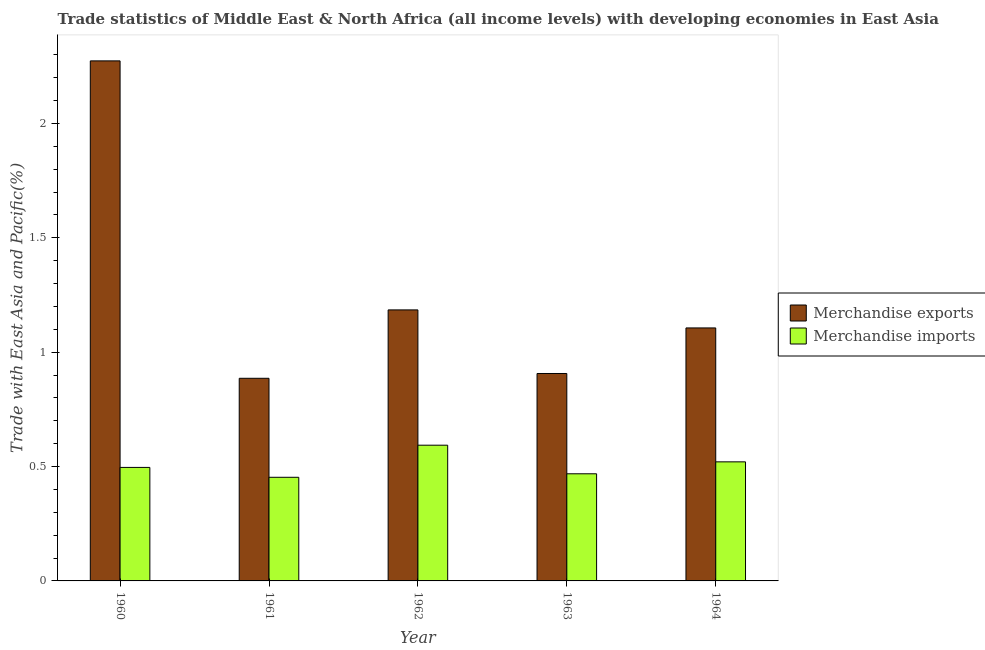How many different coloured bars are there?
Provide a short and direct response. 2. How many groups of bars are there?
Give a very brief answer. 5. How many bars are there on the 3rd tick from the left?
Your answer should be very brief. 2. How many bars are there on the 2nd tick from the right?
Your answer should be compact. 2. What is the label of the 5th group of bars from the left?
Ensure brevity in your answer.  1964. In how many cases, is the number of bars for a given year not equal to the number of legend labels?
Offer a very short reply. 0. What is the merchandise exports in 1962?
Provide a short and direct response. 1.19. Across all years, what is the maximum merchandise imports?
Give a very brief answer. 0.59. Across all years, what is the minimum merchandise exports?
Your answer should be very brief. 0.89. What is the total merchandise imports in the graph?
Your answer should be compact. 2.53. What is the difference between the merchandise imports in 1961 and that in 1963?
Offer a very short reply. -0.02. What is the difference between the merchandise exports in 1963 and the merchandise imports in 1964?
Your answer should be very brief. -0.2. What is the average merchandise imports per year?
Provide a succinct answer. 0.51. In the year 1960, what is the difference between the merchandise imports and merchandise exports?
Your answer should be compact. 0. What is the ratio of the merchandise exports in 1963 to that in 1964?
Offer a very short reply. 0.82. What is the difference between the highest and the second highest merchandise exports?
Offer a very short reply. 1.09. What is the difference between the highest and the lowest merchandise imports?
Offer a terse response. 0.14. In how many years, is the merchandise imports greater than the average merchandise imports taken over all years?
Give a very brief answer. 2. How many years are there in the graph?
Ensure brevity in your answer.  5. What is the difference between two consecutive major ticks on the Y-axis?
Give a very brief answer. 0.5. Are the values on the major ticks of Y-axis written in scientific E-notation?
Ensure brevity in your answer.  No. How many legend labels are there?
Offer a terse response. 2. How are the legend labels stacked?
Your answer should be very brief. Vertical. What is the title of the graph?
Provide a succinct answer. Trade statistics of Middle East & North Africa (all income levels) with developing economies in East Asia. What is the label or title of the X-axis?
Make the answer very short. Year. What is the label or title of the Y-axis?
Give a very brief answer. Trade with East Asia and Pacific(%). What is the Trade with East Asia and Pacific(%) in Merchandise exports in 1960?
Your answer should be compact. 2.27. What is the Trade with East Asia and Pacific(%) in Merchandise imports in 1960?
Your answer should be compact. 0.5. What is the Trade with East Asia and Pacific(%) in Merchandise exports in 1961?
Provide a succinct answer. 0.89. What is the Trade with East Asia and Pacific(%) of Merchandise imports in 1961?
Keep it short and to the point. 0.45. What is the Trade with East Asia and Pacific(%) in Merchandise exports in 1962?
Make the answer very short. 1.19. What is the Trade with East Asia and Pacific(%) in Merchandise imports in 1962?
Ensure brevity in your answer.  0.59. What is the Trade with East Asia and Pacific(%) in Merchandise exports in 1963?
Keep it short and to the point. 0.91. What is the Trade with East Asia and Pacific(%) in Merchandise imports in 1963?
Make the answer very short. 0.47. What is the Trade with East Asia and Pacific(%) of Merchandise exports in 1964?
Provide a succinct answer. 1.11. What is the Trade with East Asia and Pacific(%) in Merchandise imports in 1964?
Keep it short and to the point. 0.52. Across all years, what is the maximum Trade with East Asia and Pacific(%) in Merchandise exports?
Ensure brevity in your answer.  2.27. Across all years, what is the maximum Trade with East Asia and Pacific(%) in Merchandise imports?
Provide a succinct answer. 0.59. Across all years, what is the minimum Trade with East Asia and Pacific(%) in Merchandise exports?
Your answer should be very brief. 0.89. Across all years, what is the minimum Trade with East Asia and Pacific(%) in Merchandise imports?
Ensure brevity in your answer.  0.45. What is the total Trade with East Asia and Pacific(%) in Merchandise exports in the graph?
Your response must be concise. 6.36. What is the total Trade with East Asia and Pacific(%) in Merchandise imports in the graph?
Make the answer very short. 2.53. What is the difference between the Trade with East Asia and Pacific(%) in Merchandise exports in 1960 and that in 1961?
Your answer should be very brief. 1.39. What is the difference between the Trade with East Asia and Pacific(%) of Merchandise imports in 1960 and that in 1961?
Provide a succinct answer. 0.04. What is the difference between the Trade with East Asia and Pacific(%) of Merchandise exports in 1960 and that in 1962?
Keep it short and to the point. 1.09. What is the difference between the Trade with East Asia and Pacific(%) of Merchandise imports in 1960 and that in 1962?
Provide a succinct answer. -0.1. What is the difference between the Trade with East Asia and Pacific(%) of Merchandise exports in 1960 and that in 1963?
Keep it short and to the point. 1.37. What is the difference between the Trade with East Asia and Pacific(%) of Merchandise imports in 1960 and that in 1963?
Give a very brief answer. 0.03. What is the difference between the Trade with East Asia and Pacific(%) in Merchandise exports in 1960 and that in 1964?
Your answer should be compact. 1.17. What is the difference between the Trade with East Asia and Pacific(%) of Merchandise imports in 1960 and that in 1964?
Offer a very short reply. -0.02. What is the difference between the Trade with East Asia and Pacific(%) of Merchandise exports in 1961 and that in 1962?
Provide a short and direct response. -0.3. What is the difference between the Trade with East Asia and Pacific(%) of Merchandise imports in 1961 and that in 1962?
Keep it short and to the point. -0.14. What is the difference between the Trade with East Asia and Pacific(%) of Merchandise exports in 1961 and that in 1963?
Your response must be concise. -0.02. What is the difference between the Trade with East Asia and Pacific(%) in Merchandise imports in 1961 and that in 1963?
Give a very brief answer. -0.02. What is the difference between the Trade with East Asia and Pacific(%) of Merchandise exports in 1961 and that in 1964?
Offer a terse response. -0.22. What is the difference between the Trade with East Asia and Pacific(%) in Merchandise imports in 1961 and that in 1964?
Make the answer very short. -0.07. What is the difference between the Trade with East Asia and Pacific(%) in Merchandise exports in 1962 and that in 1963?
Provide a succinct answer. 0.28. What is the difference between the Trade with East Asia and Pacific(%) in Merchandise exports in 1962 and that in 1964?
Make the answer very short. 0.08. What is the difference between the Trade with East Asia and Pacific(%) in Merchandise imports in 1962 and that in 1964?
Make the answer very short. 0.07. What is the difference between the Trade with East Asia and Pacific(%) of Merchandise exports in 1963 and that in 1964?
Offer a terse response. -0.2. What is the difference between the Trade with East Asia and Pacific(%) of Merchandise imports in 1963 and that in 1964?
Your answer should be very brief. -0.05. What is the difference between the Trade with East Asia and Pacific(%) of Merchandise exports in 1960 and the Trade with East Asia and Pacific(%) of Merchandise imports in 1961?
Make the answer very short. 1.82. What is the difference between the Trade with East Asia and Pacific(%) in Merchandise exports in 1960 and the Trade with East Asia and Pacific(%) in Merchandise imports in 1962?
Offer a very short reply. 1.68. What is the difference between the Trade with East Asia and Pacific(%) of Merchandise exports in 1960 and the Trade with East Asia and Pacific(%) of Merchandise imports in 1963?
Ensure brevity in your answer.  1.81. What is the difference between the Trade with East Asia and Pacific(%) of Merchandise exports in 1960 and the Trade with East Asia and Pacific(%) of Merchandise imports in 1964?
Offer a very short reply. 1.75. What is the difference between the Trade with East Asia and Pacific(%) in Merchandise exports in 1961 and the Trade with East Asia and Pacific(%) in Merchandise imports in 1962?
Your answer should be very brief. 0.29. What is the difference between the Trade with East Asia and Pacific(%) in Merchandise exports in 1961 and the Trade with East Asia and Pacific(%) in Merchandise imports in 1963?
Make the answer very short. 0.42. What is the difference between the Trade with East Asia and Pacific(%) in Merchandise exports in 1961 and the Trade with East Asia and Pacific(%) in Merchandise imports in 1964?
Make the answer very short. 0.37. What is the difference between the Trade with East Asia and Pacific(%) in Merchandise exports in 1962 and the Trade with East Asia and Pacific(%) in Merchandise imports in 1963?
Make the answer very short. 0.72. What is the difference between the Trade with East Asia and Pacific(%) in Merchandise exports in 1962 and the Trade with East Asia and Pacific(%) in Merchandise imports in 1964?
Your answer should be very brief. 0.66. What is the difference between the Trade with East Asia and Pacific(%) of Merchandise exports in 1963 and the Trade with East Asia and Pacific(%) of Merchandise imports in 1964?
Offer a very short reply. 0.39. What is the average Trade with East Asia and Pacific(%) in Merchandise exports per year?
Your response must be concise. 1.27. What is the average Trade with East Asia and Pacific(%) of Merchandise imports per year?
Your answer should be very brief. 0.51. In the year 1960, what is the difference between the Trade with East Asia and Pacific(%) in Merchandise exports and Trade with East Asia and Pacific(%) in Merchandise imports?
Offer a terse response. 1.78. In the year 1961, what is the difference between the Trade with East Asia and Pacific(%) of Merchandise exports and Trade with East Asia and Pacific(%) of Merchandise imports?
Provide a succinct answer. 0.43. In the year 1962, what is the difference between the Trade with East Asia and Pacific(%) in Merchandise exports and Trade with East Asia and Pacific(%) in Merchandise imports?
Ensure brevity in your answer.  0.59. In the year 1963, what is the difference between the Trade with East Asia and Pacific(%) in Merchandise exports and Trade with East Asia and Pacific(%) in Merchandise imports?
Ensure brevity in your answer.  0.44. In the year 1964, what is the difference between the Trade with East Asia and Pacific(%) of Merchandise exports and Trade with East Asia and Pacific(%) of Merchandise imports?
Ensure brevity in your answer.  0.59. What is the ratio of the Trade with East Asia and Pacific(%) in Merchandise exports in 1960 to that in 1961?
Your response must be concise. 2.57. What is the ratio of the Trade with East Asia and Pacific(%) of Merchandise imports in 1960 to that in 1961?
Offer a very short reply. 1.1. What is the ratio of the Trade with East Asia and Pacific(%) of Merchandise exports in 1960 to that in 1962?
Your answer should be compact. 1.92. What is the ratio of the Trade with East Asia and Pacific(%) of Merchandise imports in 1960 to that in 1962?
Your answer should be very brief. 0.84. What is the ratio of the Trade with East Asia and Pacific(%) in Merchandise exports in 1960 to that in 1963?
Give a very brief answer. 2.51. What is the ratio of the Trade with East Asia and Pacific(%) of Merchandise imports in 1960 to that in 1963?
Offer a terse response. 1.06. What is the ratio of the Trade with East Asia and Pacific(%) in Merchandise exports in 1960 to that in 1964?
Keep it short and to the point. 2.06. What is the ratio of the Trade with East Asia and Pacific(%) in Merchandise imports in 1960 to that in 1964?
Provide a short and direct response. 0.95. What is the ratio of the Trade with East Asia and Pacific(%) of Merchandise exports in 1961 to that in 1962?
Make the answer very short. 0.75. What is the ratio of the Trade with East Asia and Pacific(%) in Merchandise imports in 1961 to that in 1962?
Offer a terse response. 0.76. What is the ratio of the Trade with East Asia and Pacific(%) in Merchandise exports in 1961 to that in 1963?
Your answer should be very brief. 0.98. What is the ratio of the Trade with East Asia and Pacific(%) in Merchandise imports in 1961 to that in 1963?
Offer a very short reply. 0.97. What is the ratio of the Trade with East Asia and Pacific(%) of Merchandise exports in 1961 to that in 1964?
Ensure brevity in your answer.  0.8. What is the ratio of the Trade with East Asia and Pacific(%) in Merchandise imports in 1961 to that in 1964?
Ensure brevity in your answer.  0.87. What is the ratio of the Trade with East Asia and Pacific(%) of Merchandise exports in 1962 to that in 1963?
Your answer should be very brief. 1.31. What is the ratio of the Trade with East Asia and Pacific(%) in Merchandise imports in 1962 to that in 1963?
Provide a succinct answer. 1.27. What is the ratio of the Trade with East Asia and Pacific(%) in Merchandise exports in 1962 to that in 1964?
Offer a very short reply. 1.07. What is the ratio of the Trade with East Asia and Pacific(%) of Merchandise imports in 1962 to that in 1964?
Provide a succinct answer. 1.14. What is the ratio of the Trade with East Asia and Pacific(%) in Merchandise exports in 1963 to that in 1964?
Offer a terse response. 0.82. What is the ratio of the Trade with East Asia and Pacific(%) in Merchandise imports in 1963 to that in 1964?
Provide a short and direct response. 0.9. What is the difference between the highest and the second highest Trade with East Asia and Pacific(%) of Merchandise exports?
Make the answer very short. 1.09. What is the difference between the highest and the second highest Trade with East Asia and Pacific(%) in Merchandise imports?
Ensure brevity in your answer.  0.07. What is the difference between the highest and the lowest Trade with East Asia and Pacific(%) of Merchandise exports?
Your response must be concise. 1.39. What is the difference between the highest and the lowest Trade with East Asia and Pacific(%) in Merchandise imports?
Your response must be concise. 0.14. 